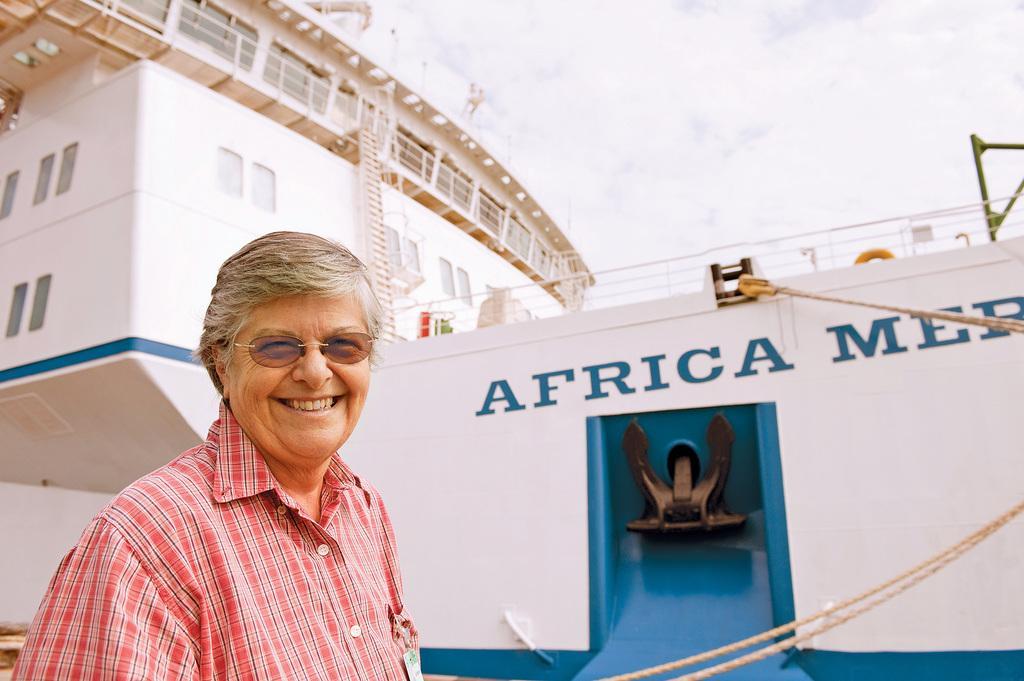Can you describe this image briefly? In this image we can see a man wearing glasses and smiling. In the background there is a white color ship with text. We can also see the ropes. There is sky with the clouds. 